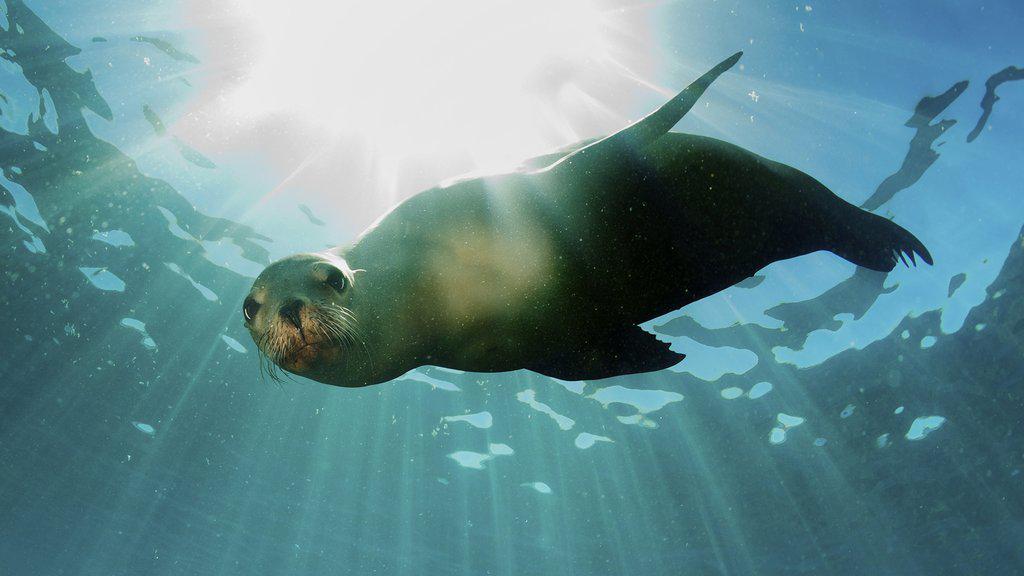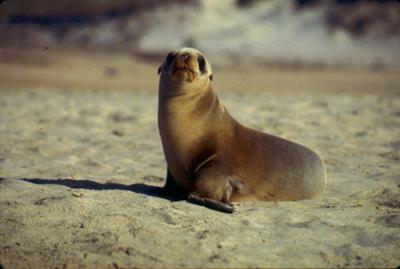The first image is the image on the left, the second image is the image on the right. Evaluate the accuracy of this statement regarding the images: "There is at least one seal resting on a solid surface". Is it true? Answer yes or no. Yes. 